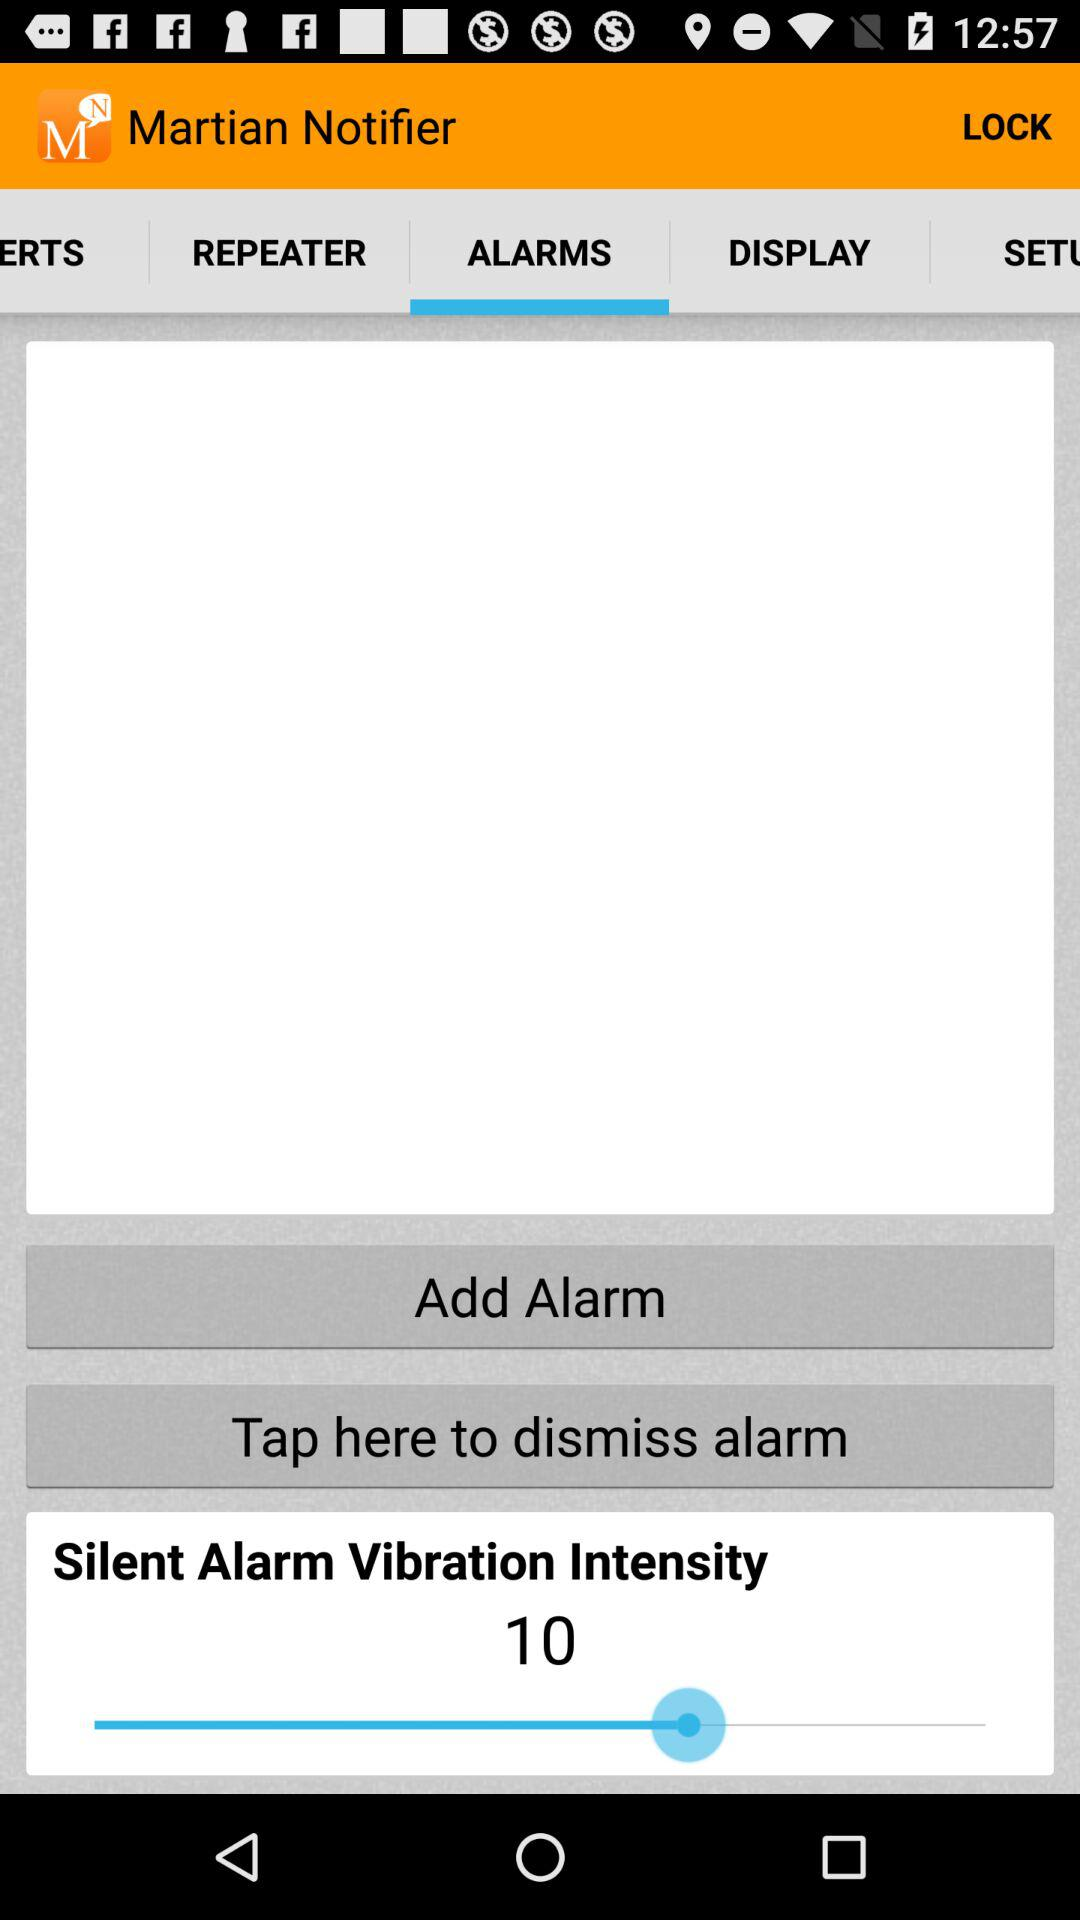When will the alarm go off?
When the provided information is insufficient, respond with <no answer>. <no answer> 